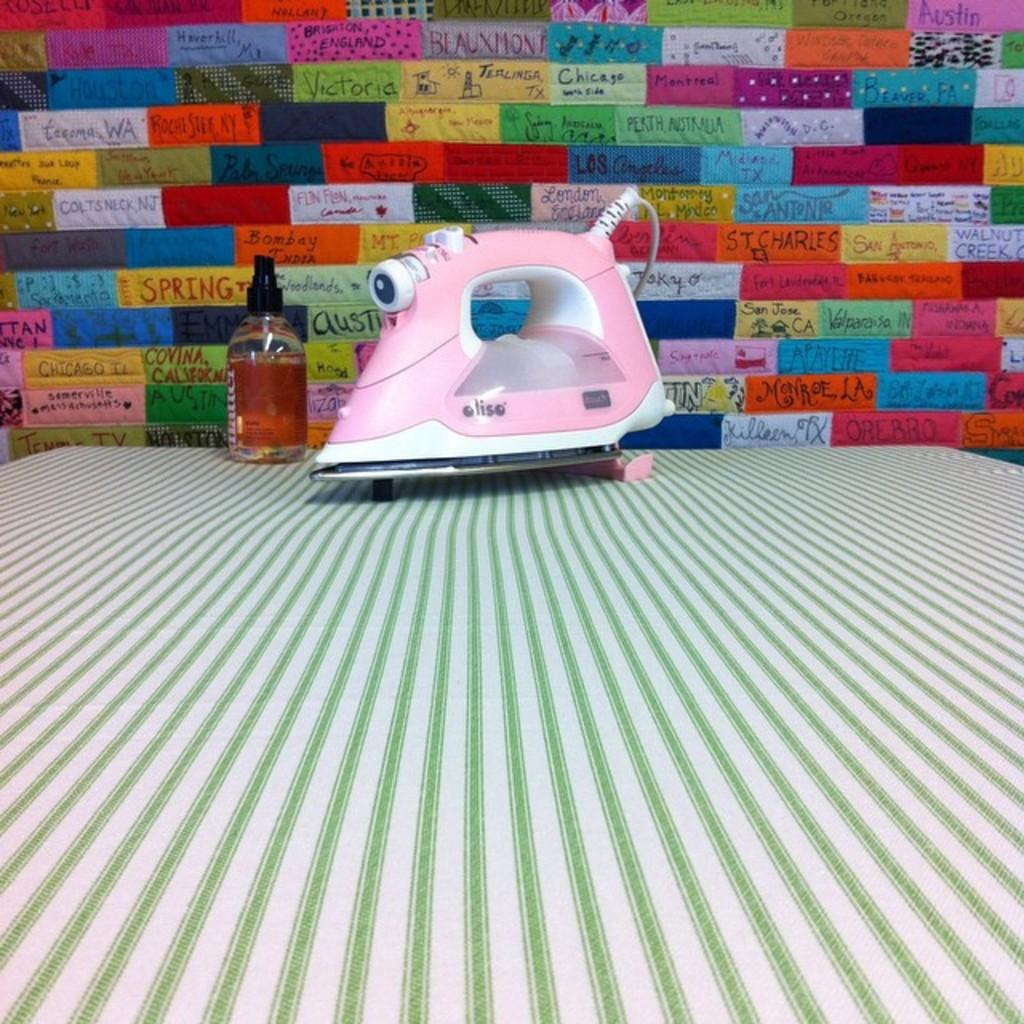What object is in the image that is made of metal? There is an iron box in the image. What is the iron box placed on? The iron box is placed on a cloth. What can be seen beside the iron box? There is a bottle with liquid beside the iron box. What can be observed in the background of the image? The background of the image includes a wall with several colors. What type of shade is covering the iron box in the image? There is no shade covering the iron box in the image. 